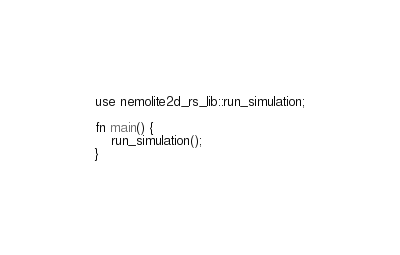Convert code to text. <code><loc_0><loc_0><loc_500><loc_500><_Rust_>use nemolite2d_rs_lib::run_simulation;

fn main() {
    run_simulation();
}
</code> 